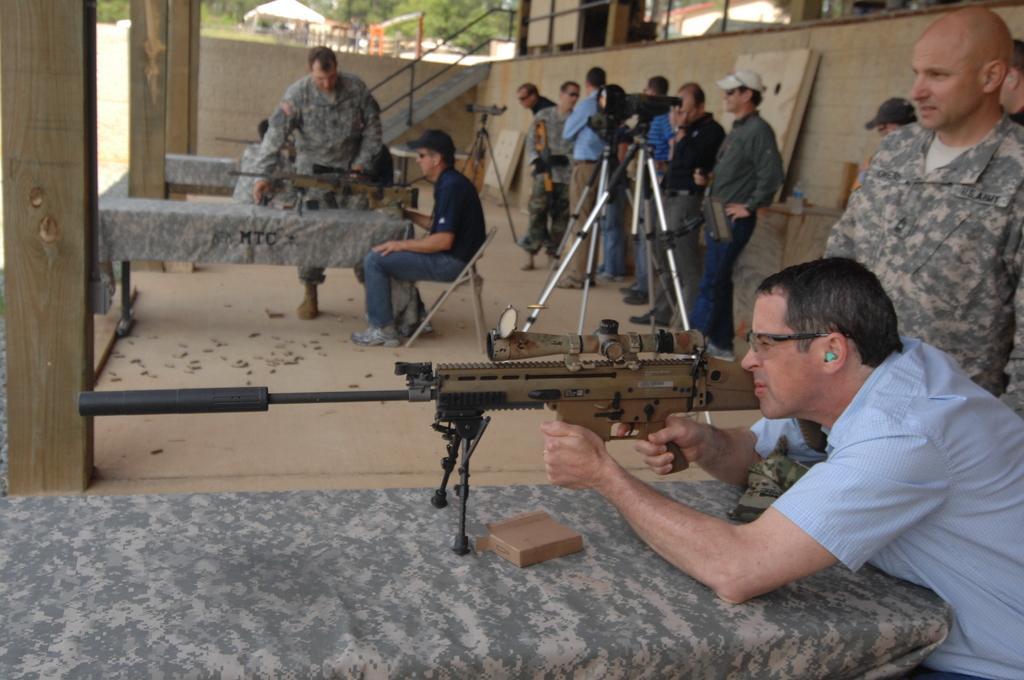Describe this image in one or two sentences. There are people, this man sitting on a chair and this man holding a gun. We can see guns and box on tables. In the background we can see wall, railing, steps, trees and tent. Here we can see bottle and objects on the table. 